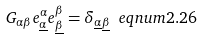<formula> <loc_0><loc_0><loc_500><loc_500>G _ { \alpha \beta } e _ { \underline { \alpha } } ^ { \alpha } e _ { \underline { \beta } } ^ { \beta } = \delta _ { \underline { \alpha } \underline { \beta } } \ e q n u m { 2 . 2 6 }</formula> 